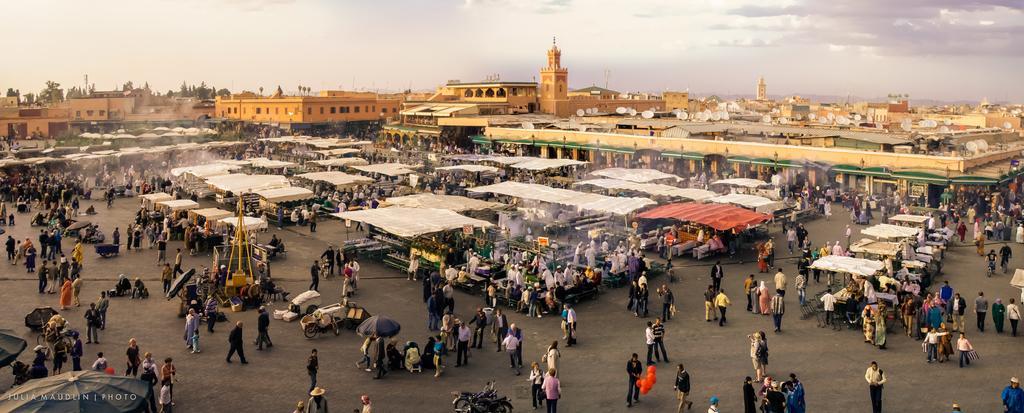Can you describe this image briefly? In this image we can see the overall view of the city where we can see there is market in the middle. where there are so many people walking on the road. In the background there are buildings. Some people are standing by holding the umbrellas. At the top there is the sky. 